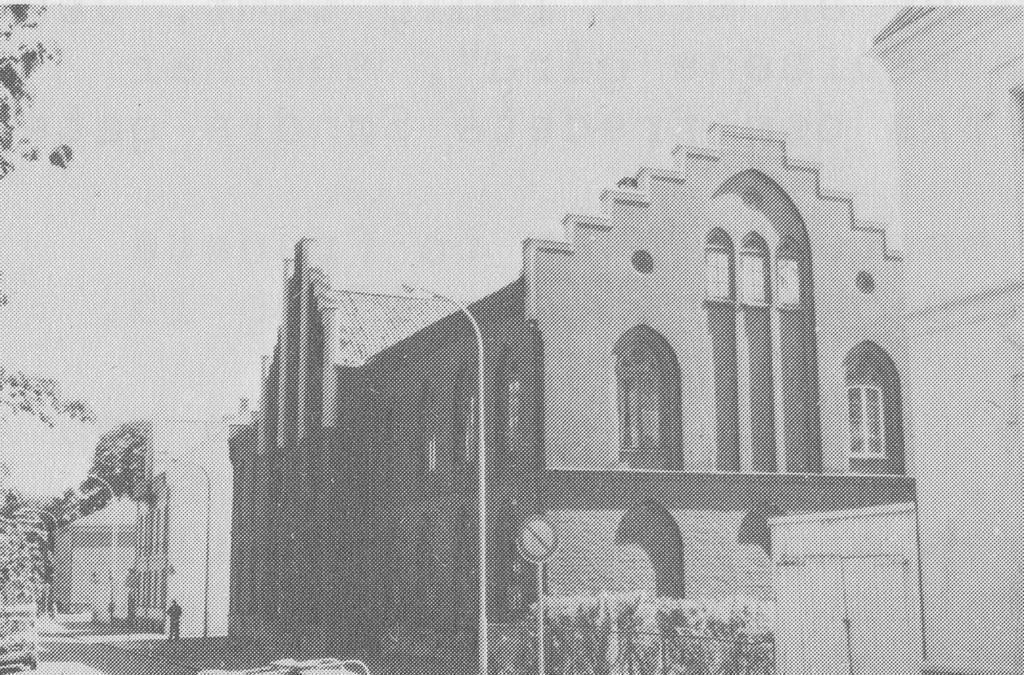Can you describe this image briefly? This is a sketch and here we can see buildings, light poles, boards and there are vehicles on the road, trees and there is a person and a fence. 